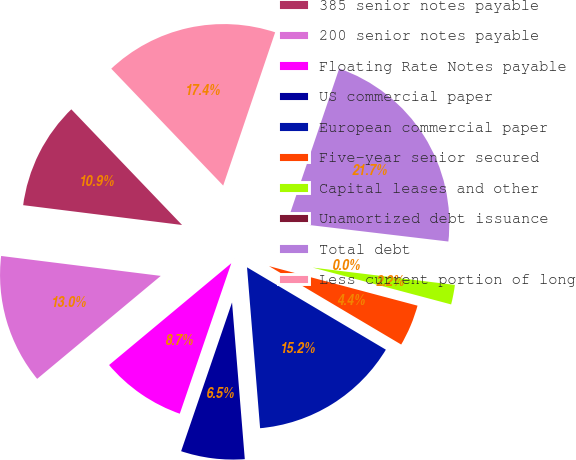<chart> <loc_0><loc_0><loc_500><loc_500><pie_chart><fcel>385 senior notes payable<fcel>200 senior notes payable<fcel>Floating Rate Notes payable<fcel>US commercial paper<fcel>European commercial paper<fcel>Five-year senior secured<fcel>Capital leases and other<fcel>Unamortized debt issuance<fcel>Total debt<fcel>Less current portion of long<nl><fcel>10.87%<fcel>13.03%<fcel>8.7%<fcel>6.54%<fcel>15.19%<fcel>4.38%<fcel>2.21%<fcel>0.05%<fcel>21.68%<fcel>17.36%<nl></chart> 